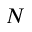<formula> <loc_0><loc_0><loc_500><loc_500>N</formula> 